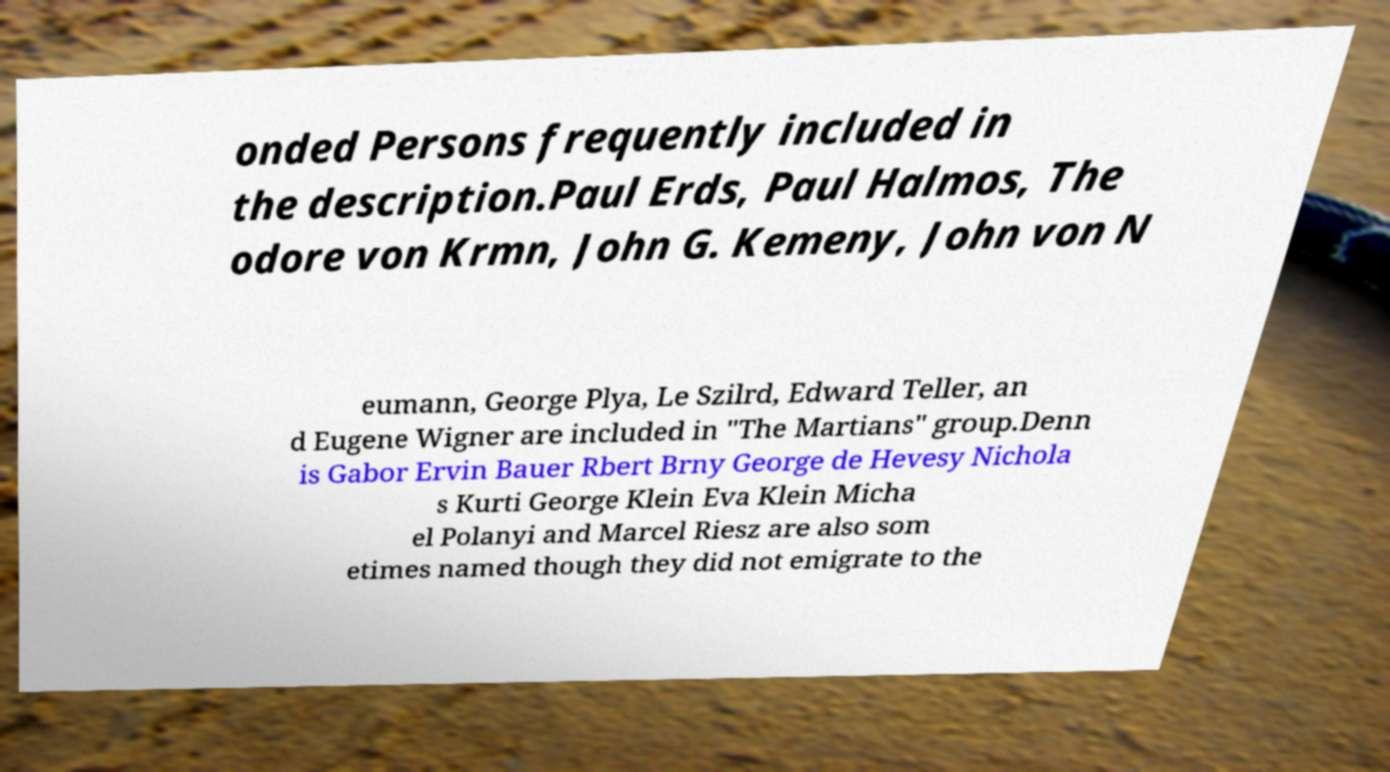There's text embedded in this image that I need extracted. Can you transcribe it verbatim? onded Persons frequently included in the description.Paul Erds, Paul Halmos, The odore von Krmn, John G. Kemeny, John von N eumann, George Plya, Le Szilrd, Edward Teller, an d Eugene Wigner are included in "The Martians" group.Denn is Gabor Ervin Bauer Rbert Brny George de Hevesy Nichola s Kurti George Klein Eva Klein Micha el Polanyi and Marcel Riesz are also som etimes named though they did not emigrate to the 